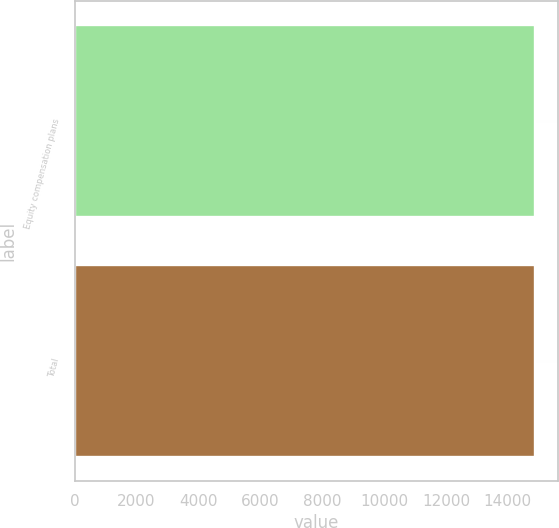Convert chart to OTSL. <chart><loc_0><loc_0><loc_500><loc_500><bar_chart><fcel>Equity compensation plans<fcel>Total<nl><fcel>14866<fcel>14866.1<nl></chart> 